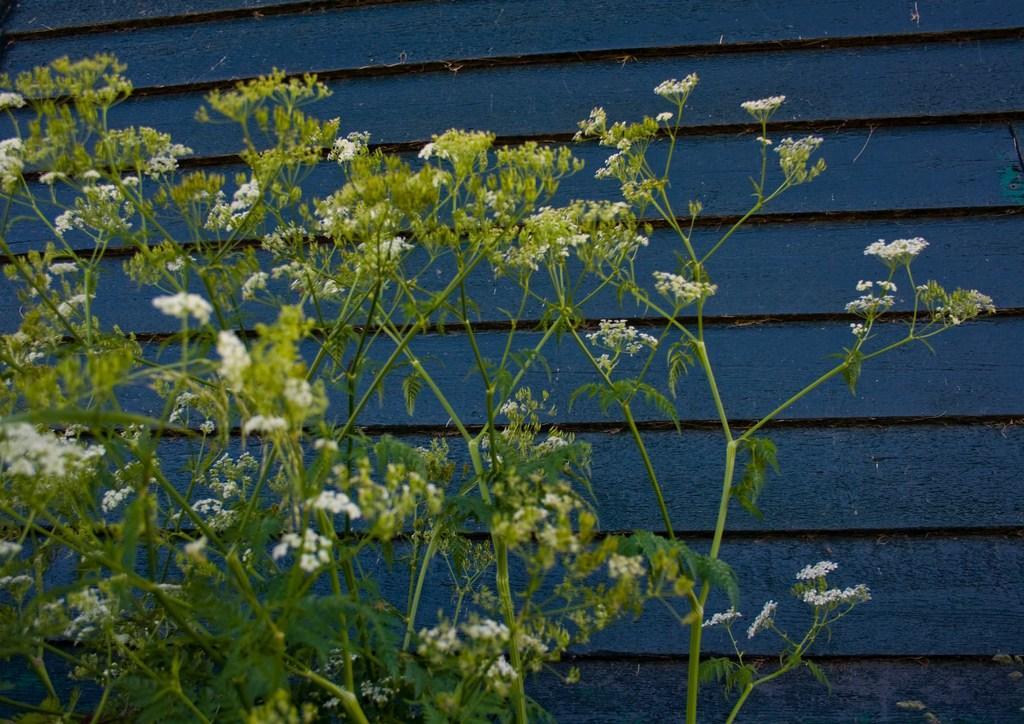Describe this image in one or two sentences. In this image there are few plants having flowers and leaves. Behind it there is a wooden wall which is painted in blue color. 